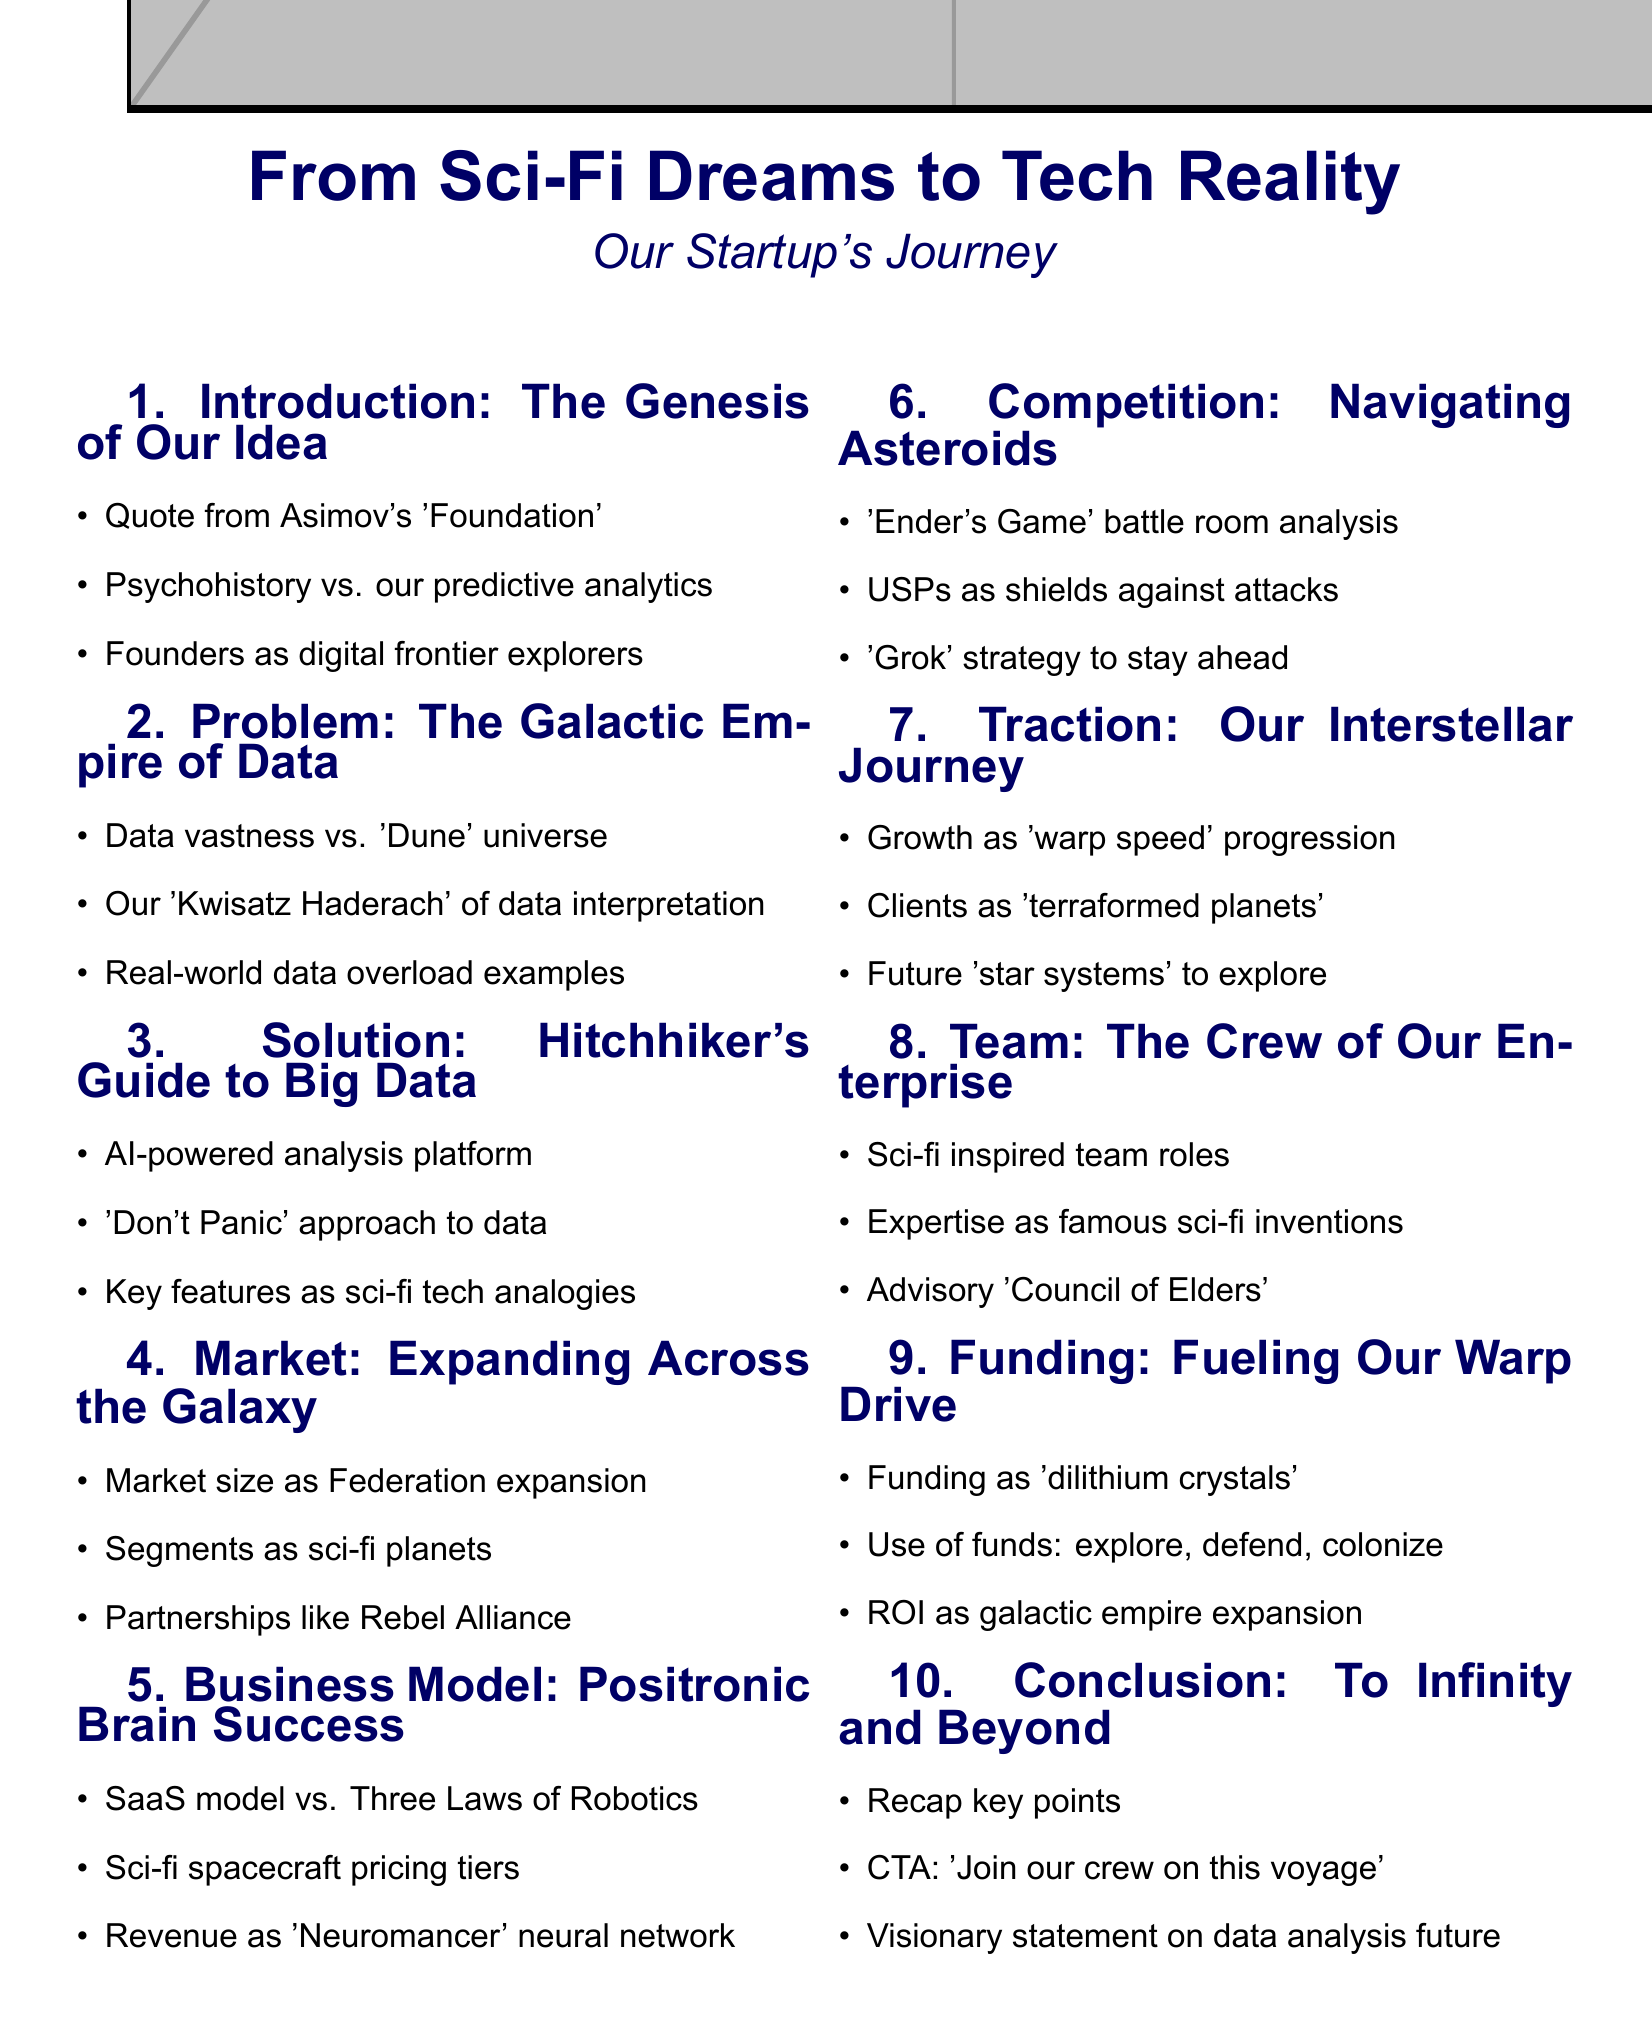What is the title of the presentation? The title of the presentation is stated at the beginning of the document.
Answer: From Sci-Fi Dreams to Tech Reality: Our Startup's Journey Who is the author of the quote used in the introduction? The document specifies a quote from a famous author, which is Isaac Asimov.
Answer: Isaac Asimov What concept does the startup compare its predictive analytics to? The document mentions a specific sci-fi concept that is analogous to their technology, psychohistory.
Answer: Psychohistory What is the inspiration for the solution presented? The document reflects on a well-known sci-fi work that inspired the solution, which is Douglas Adams' book.
Answer: The Hitchhiker's Guide to the Galaxy What model does the business operate under? The document details the business model employed, specifically mentioning a common software delivery model.
Answer: SaaS What are the key funding categories listed in the funding ask? The document outlines specific uses for the funds, categorizing them in three areas.
Answer: Exploration, defense, colonization What is used to visualize the projected revenue streams? The document explains a specific visual analogy representing revenue streams based on a sci-fi concept.
Answer: Neural network How are market segments named? The document uses a creative naming approach for market segments, linking them to specific locations in sci-fi literature.
Answer: Planets from various sci-fi universes What literary device is primarily used throughout the presentation? The document illustrates a style of presentation that enhances engagement through storytelling techniques.
Answer: Storytelling 